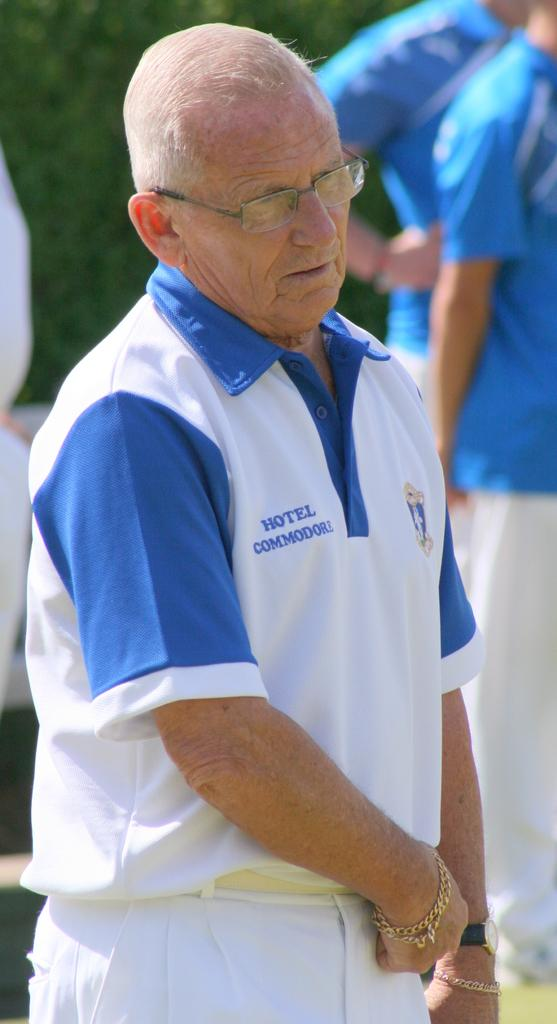<image>
Render a clear and concise summary of the photo. older man wearing gold bracelets and a hotel commodore shirt 